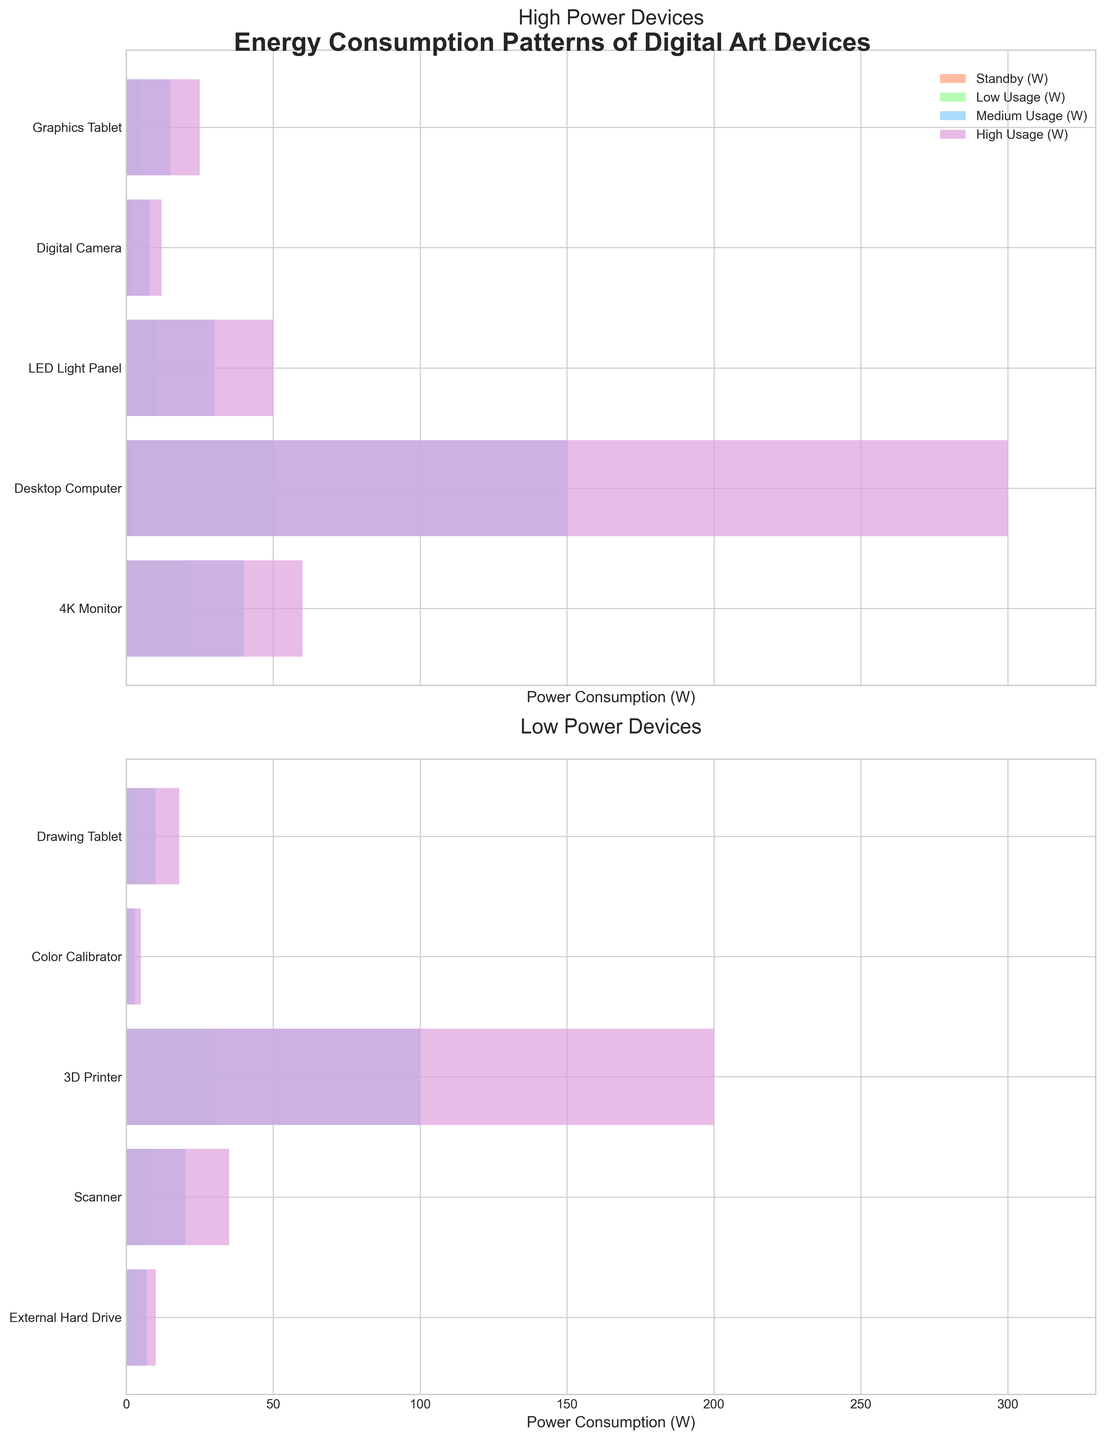How many devices are categorized under 'High Power Devices' according to the plot? The title of the first subplot is 'High Power Devices,' and from the y-axis, we can count that there are 5 devices listed.
Answer: 5 What is the maximum power consumption in High Usage (W) for the devices in the 'High Power Devices' category? In the first subplot titled 'High Power Devices,' the bar representing 'High Usage (W)' for the Desktop Computer is the longest, with a value of 300 W.
Answer: 300 W Which device has the lowest power consumption in Standby (W) among the 'Low Power Devices' category? In the second subplot titled 'Low Power Devices,' the shortest bar under the 'Standby (W)' category is for the LED Light Panel, with a value of 0.1 W.
Answer: LED Light Panel Compare the Medium Usage (W) consumption between the 3D Printer and the Digital Camera. Which one consumes more? In the first subplot titled 'High Power Devices,' the bar representing 'Medium Usage (W)' for the 3D Printer is longer than that for the Digital Camera, indicating higher power consumption. The 3D Printer consumes 100 W, while the Digital Camera consumes 8 W.
Answer: 3D Printer What are the average Standby (W) consumptions of the devices in the 'Low Power Devices' category? The Standby (W) consumptions for the devices in the second subplot 'Low Power Devices' are 0.1, 0.3, 0.1, 0.4, 0.2 W. The average can be calculated as (0.1 + 0.3 + 0.1 + 0.4 + 0.2) / 5 = 1.1 / 5 = 0.22 W.
Answer: 0.22 W Which device in the 'High Power Devices' category experiences a significant increase in power consumption from Low Usage (W) to Medium Usage (W)? In the first subplot, the 3D Printer shows a significant increase in power consumption from Low Usage (W) at 30 W to Medium Usage (W) at 100 W, which is the biggest jump compared to other devices.
Answer: 3D Printer 